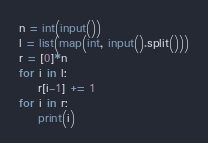<code> <loc_0><loc_0><loc_500><loc_500><_Python_>n = int(input())
l = list(map(int, input().split()))
r = [0]*n
for i in l:
    r[i-1] += 1
for i in r:
    print(i)</code> 